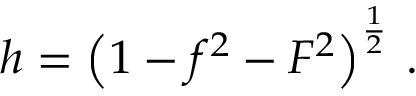<formula> <loc_0><loc_0><loc_500><loc_500>h = \left ( 1 - f ^ { 2 } - F ^ { 2 } \right ) ^ { \frac { 1 } { 2 } } \, .</formula> 